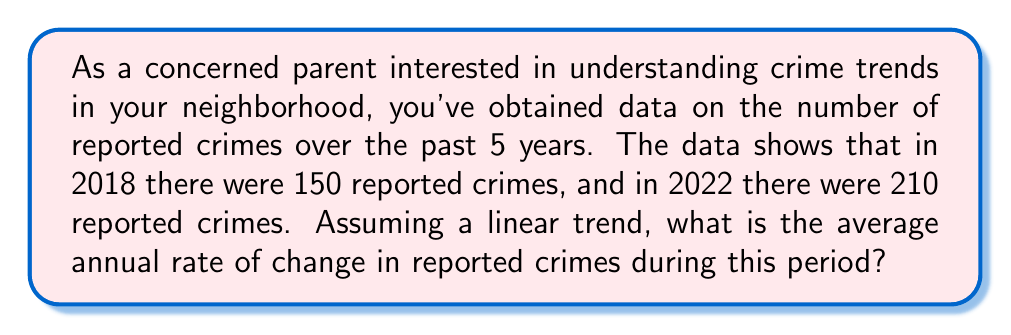Give your solution to this math problem. To solve this problem, we'll use the concept of rate of change, which is similar to the slope of a line. Here's how we can approach it:

1. Identify the important information:
   - Initial year (2018) and initial number of crimes (150)
   - Final year (2022) and final number of crimes (210)
   - Time period: 5 years (2022 - 2018 + 1)

2. Calculate the total change in reported crimes:
   $\text{Total change} = \text{Final value} - \text{Initial value}$
   $\text{Total change} = 210 - 150 = 60$ crimes

3. Calculate the rate of change using the formula:
   $$\text{Rate of change} = \frac{\text{Change in y}}{\text{Change in x}} = \frac{\text{Change in crimes}}{\text{Change in years}}$$

4. Plug in the values:
   $$\text{Rate of change} = \frac{60 \text{ crimes}}{5 \text{ years}} = 12 \text{ crimes per year}$$

This result means that, on average, the number of reported crimes increased by 12 each year from 2018 to 2022, assuming a linear trend.
Answer: The average annual rate of change in reported crimes is 12 crimes per year. 